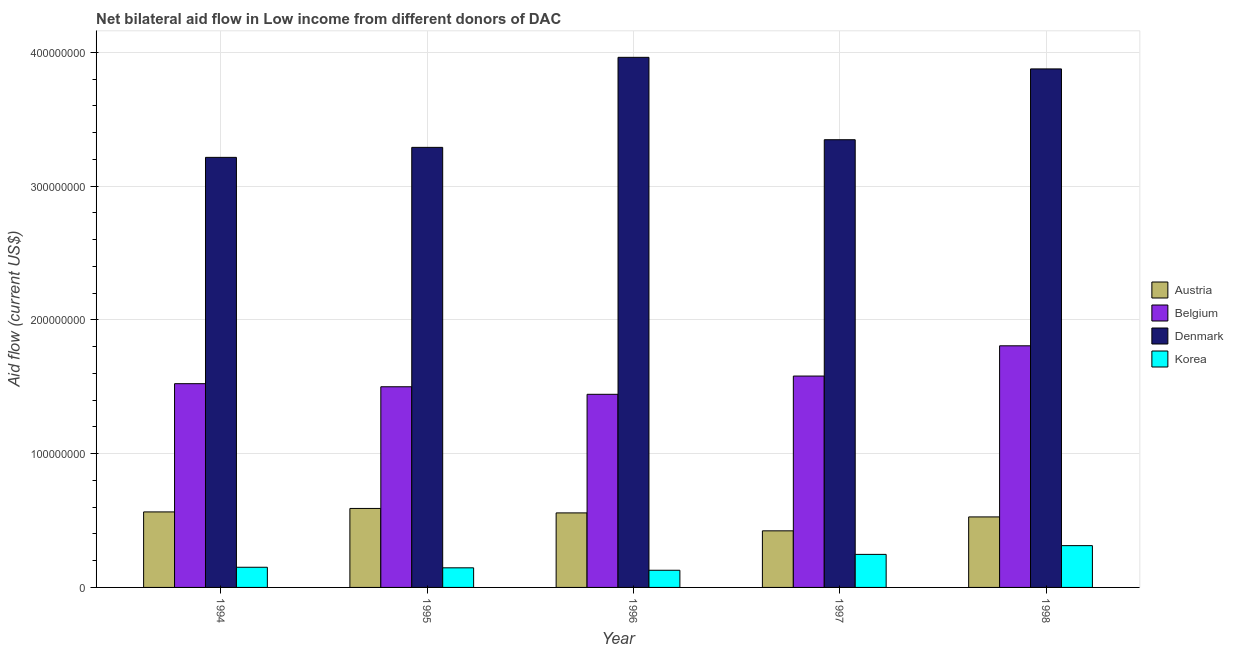Are the number of bars per tick equal to the number of legend labels?
Offer a terse response. Yes. Are the number of bars on each tick of the X-axis equal?
Give a very brief answer. Yes. How many bars are there on the 4th tick from the right?
Ensure brevity in your answer.  4. In how many cases, is the number of bars for a given year not equal to the number of legend labels?
Ensure brevity in your answer.  0. What is the amount of aid given by austria in 1997?
Provide a short and direct response. 4.23e+07. Across all years, what is the maximum amount of aid given by korea?
Keep it short and to the point. 3.12e+07. Across all years, what is the minimum amount of aid given by denmark?
Keep it short and to the point. 3.21e+08. What is the total amount of aid given by austria in the graph?
Offer a very short reply. 2.66e+08. What is the difference between the amount of aid given by denmark in 1994 and that in 1997?
Make the answer very short. -1.32e+07. What is the difference between the amount of aid given by austria in 1997 and the amount of aid given by korea in 1994?
Provide a short and direct response. -1.42e+07. What is the average amount of aid given by austria per year?
Your response must be concise. 5.32e+07. In how many years, is the amount of aid given by austria greater than 240000000 US$?
Ensure brevity in your answer.  0. What is the ratio of the amount of aid given by belgium in 1996 to that in 1997?
Give a very brief answer. 0.91. What is the difference between the highest and the second highest amount of aid given by denmark?
Keep it short and to the point. 8.66e+06. What is the difference between the highest and the lowest amount of aid given by korea?
Offer a very short reply. 1.84e+07. Is the sum of the amount of aid given by korea in 1997 and 1998 greater than the maximum amount of aid given by denmark across all years?
Ensure brevity in your answer.  Yes. Is it the case that in every year, the sum of the amount of aid given by korea and amount of aid given by denmark is greater than the sum of amount of aid given by austria and amount of aid given by belgium?
Offer a terse response. No. What does the 4th bar from the left in 1995 represents?
Your answer should be compact. Korea. Is it the case that in every year, the sum of the amount of aid given by austria and amount of aid given by belgium is greater than the amount of aid given by denmark?
Offer a terse response. No. Are the values on the major ticks of Y-axis written in scientific E-notation?
Your response must be concise. No. What is the title of the graph?
Offer a terse response. Net bilateral aid flow in Low income from different donors of DAC. What is the label or title of the X-axis?
Provide a short and direct response. Year. What is the Aid flow (current US$) in Austria in 1994?
Make the answer very short. 5.64e+07. What is the Aid flow (current US$) in Belgium in 1994?
Give a very brief answer. 1.52e+08. What is the Aid flow (current US$) in Denmark in 1994?
Provide a succinct answer. 3.21e+08. What is the Aid flow (current US$) in Korea in 1994?
Ensure brevity in your answer.  1.51e+07. What is the Aid flow (current US$) of Austria in 1995?
Your response must be concise. 5.90e+07. What is the Aid flow (current US$) of Belgium in 1995?
Your response must be concise. 1.50e+08. What is the Aid flow (current US$) of Denmark in 1995?
Your answer should be very brief. 3.29e+08. What is the Aid flow (current US$) of Korea in 1995?
Provide a succinct answer. 1.47e+07. What is the Aid flow (current US$) in Austria in 1996?
Provide a short and direct response. 5.57e+07. What is the Aid flow (current US$) in Belgium in 1996?
Provide a succinct answer. 1.44e+08. What is the Aid flow (current US$) in Denmark in 1996?
Your response must be concise. 3.96e+08. What is the Aid flow (current US$) of Korea in 1996?
Provide a short and direct response. 1.28e+07. What is the Aid flow (current US$) in Austria in 1997?
Offer a terse response. 4.23e+07. What is the Aid flow (current US$) in Belgium in 1997?
Offer a terse response. 1.58e+08. What is the Aid flow (current US$) in Denmark in 1997?
Offer a terse response. 3.35e+08. What is the Aid flow (current US$) of Korea in 1997?
Make the answer very short. 2.47e+07. What is the Aid flow (current US$) in Austria in 1998?
Your answer should be very brief. 5.27e+07. What is the Aid flow (current US$) in Belgium in 1998?
Your answer should be very brief. 1.81e+08. What is the Aid flow (current US$) in Denmark in 1998?
Your answer should be very brief. 3.88e+08. What is the Aid flow (current US$) in Korea in 1998?
Provide a short and direct response. 3.12e+07. Across all years, what is the maximum Aid flow (current US$) in Austria?
Your answer should be compact. 5.90e+07. Across all years, what is the maximum Aid flow (current US$) in Belgium?
Offer a terse response. 1.81e+08. Across all years, what is the maximum Aid flow (current US$) of Denmark?
Provide a short and direct response. 3.96e+08. Across all years, what is the maximum Aid flow (current US$) of Korea?
Your answer should be compact. 3.12e+07. Across all years, what is the minimum Aid flow (current US$) of Austria?
Give a very brief answer. 4.23e+07. Across all years, what is the minimum Aid flow (current US$) of Belgium?
Offer a very short reply. 1.44e+08. Across all years, what is the minimum Aid flow (current US$) of Denmark?
Your response must be concise. 3.21e+08. Across all years, what is the minimum Aid flow (current US$) in Korea?
Provide a short and direct response. 1.28e+07. What is the total Aid flow (current US$) in Austria in the graph?
Ensure brevity in your answer.  2.66e+08. What is the total Aid flow (current US$) of Belgium in the graph?
Give a very brief answer. 7.85e+08. What is the total Aid flow (current US$) in Denmark in the graph?
Your answer should be very brief. 1.77e+09. What is the total Aid flow (current US$) in Korea in the graph?
Provide a succinct answer. 9.85e+07. What is the difference between the Aid flow (current US$) in Austria in 1994 and that in 1995?
Your answer should be very brief. -2.59e+06. What is the difference between the Aid flow (current US$) in Belgium in 1994 and that in 1995?
Ensure brevity in your answer.  2.29e+06. What is the difference between the Aid flow (current US$) of Denmark in 1994 and that in 1995?
Make the answer very short. -7.47e+06. What is the difference between the Aid flow (current US$) in Korea in 1994 and that in 1995?
Your answer should be very brief. 4.20e+05. What is the difference between the Aid flow (current US$) of Austria in 1994 and that in 1996?
Your response must be concise. 7.40e+05. What is the difference between the Aid flow (current US$) of Belgium in 1994 and that in 1996?
Keep it short and to the point. 7.94e+06. What is the difference between the Aid flow (current US$) in Denmark in 1994 and that in 1996?
Your answer should be compact. -7.48e+07. What is the difference between the Aid flow (current US$) in Korea in 1994 and that in 1996?
Keep it short and to the point. 2.25e+06. What is the difference between the Aid flow (current US$) in Austria in 1994 and that in 1997?
Give a very brief answer. 1.42e+07. What is the difference between the Aid flow (current US$) of Belgium in 1994 and that in 1997?
Ensure brevity in your answer.  -5.70e+06. What is the difference between the Aid flow (current US$) in Denmark in 1994 and that in 1997?
Ensure brevity in your answer.  -1.32e+07. What is the difference between the Aid flow (current US$) in Korea in 1994 and that in 1997?
Offer a very short reply. -9.62e+06. What is the difference between the Aid flow (current US$) of Austria in 1994 and that in 1998?
Ensure brevity in your answer.  3.74e+06. What is the difference between the Aid flow (current US$) of Belgium in 1994 and that in 1998?
Offer a terse response. -2.83e+07. What is the difference between the Aid flow (current US$) of Denmark in 1994 and that in 1998?
Give a very brief answer. -6.61e+07. What is the difference between the Aid flow (current US$) in Korea in 1994 and that in 1998?
Your answer should be compact. -1.62e+07. What is the difference between the Aid flow (current US$) of Austria in 1995 and that in 1996?
Your answer should be very brief. 3.33e+06. What is the difference between the Aid flow (current US$) of Belgium in 1995 and that in 1996?
Give a very brief answer. 5.65e+06. What is the difference between the Aid flow (current US$) in Denmark in 1995 and that in 1996?
Offer a terse response. -6.73e+07. What is the difference between the Aid flow (current US$) in Korea in 1995 and that in 1996?
Make the answer very short. 1.83e+06. What is the difference between the Aid flow (current US$) of Austria in 1995 and that in 1997?
Keep it short and to the point. 1.67e+07. What is the difference between the Aid flow (current US$) in Belgium in 1995 and that in 1997?
Provide a succinct answer. -7.99e+06. What is the difference between the Aid flow (current US$) in Denmark in 1995 and that in 1997?
Provide a short and direct response. -5.72e+06. What is the difference between the Aid flow (current US$) of Korea in 1995 and that in 1997?
Offer a terse response. -1.00e+07. What is the difference between the Aid flow (current US$) in Austria in 1995 and that in 1998?
Give a very brief answer. 6.33e+06. What is the difference between the Aid flow (current US$) in Belgium in 1995 and that in 1998?
Make the answer very short. -3.06e+07. What is the difference between the Aid flow (current US$) of Denmark in 1995 and that in 1998?
Your answer should be very brief. -5.86e+07. What is the difference between the Aid flow (current US$) in Korea in 1995 and that in 1998?
Offer a terse response. -1.66e+07. What is the difference between the Aid flow (current US$) in Austria in 1996 and that in 1997?
Give a very brief answer. 1.34e+07. What is the difference between the Aid flow (current US$) in Belgium in 1996 and that in 1997?
Offer a terse response. -1.36e+07. What is the difference between the Aid flow (current US$) of Denmark in 1996 and that in 1997?
Your answer should be compact. 6.16e+07. What is the difference between the Aid flow (current US$) of Korea in 1996 and that in 1997?
Your response must be concise. -1.19e+07. What is the difference between the Aid flow (current US$) of Austria in 1996 and that in 1998?
Your answer should be compact. 3.00e+06. What is the difference between the Aid flow (current US$) in Belgium in 1996 and that in 1998?
Offer a very short reply. -3.63e+07. What is the difference between the Aid flow (current US$) in Denmark in 1996 and that in 1998?
Give a very brief answer. 8.66e+06. What is the difference between the Aid flow (current US$) in Korea in 1996 and that in 1998?
Provide a succinct answer. -1.84e+07. What is the difference between the Aid flow (current US$) of Austria in 1997 and that in 1998?
Your answer should be compact. -1.04e+07. What is the difference between the Aid flow (current US$) of Belgium in 1997 and that in 1998?
Your answer should be compact. -2.26e+07. What is the difference between the Aid flow (current US$) in Denmark in 1997 and that in 1998?
Provide a short and direct response. -5.29e+07. What is the difference between the Aid flow (current US$) of Korea in 1997 and that in 1998?
Make the answer very short. -6.54e+06. What is the difference between the Aid flow (current US$) of Austria in 1994 and the Aid flow (current US$) of Belgium in 1995?
Your answer should be compact. -9.36e+07. What is the difference between the Aid flow (current US$) of Austria in 1994 and the Aid flow (current US$) of Denmark in 1995?
Make the answer very short. -2.72e+08. What is the difference between the Aid flow (current US$) of Austria in 1994 and the Aid flow (current US$) of Korea in 1995?
Keep it short and to the point. 4.18e+07. What is the difference between the Aid flow (current US$) in Belgium in 1994 and the Aid flow (current US$) in Denmark in 1995?
Provide a short and direct response. -1.77e+08. What is the difference between the Aid flow (current US$) in Belgium in 1994 and the Aid flow (current US$) in Korea in 1995?
Your answer should be compact. 1.38e+08. What is the difference between the Aid flow (current US$) in Denmark in 1994 and the Aid flow (current US$) in Korea in 1995?
Your answer should be very brief. 3.07e+08. What is the difference between the Aid flow (current US$) of Austria in 1994 and the Aid flow (current US$) of Belgium in 1996?
Provide a succinct answer. -8.79e+07. What is the difference between the Aid flow (current US$) in Austria in 1994 and the Aid flow (current US$) in Denmark in 1996?
Provide a short and direct response. -3.40e+08. What is the difference between the Aid flow (current US$) in Austria in 1994 and the Aid flow (current US$) in Korea in 1996?
Offer a very short reply. 4.36e+07. What is the difference between the Aid flow (current US$) of Belgium in 1994 and the Aid flow (current US$) of Denmark in 1996?
Make the answer very short. -2.44e+08. What is the difference between the Aid flow (current US$) of Belgium in 1994 and the Aid flow (current US$) of Korea in 1996?
Ensure brevity in your answer.  1.39e+08. What is the difference between the Aid flow (current US$) of Denmark in 1994 and the Aid flow (current US$) of Korea in 1996?
Your answer should be compact. 3.09e+08. What is the difference between the Aid flow (current US$) in Austria in 1994 and the Aid flow (current US$) in Belgium in 1997?
Ensure brevity in your answer.  -1.02e+08. What is the difference between the Aid flow (current US$) in Austria in 1994 and the Aid flow (current US$) in Denmark in 1997?
Your response must be concise. -2.78e+08. What is the difference between the Aid flow (current US$) of Austria in 1994 and the Aid flow (current US$) of Korea in 1997?
Offer a very short reply. 3.18e+07. What is the difference between the Aid flow (current US$) in Belgium in 1994 and the Aid flow (current US$) in Denmark in 1997?
Provide a succinct answer. -1.82e+08. What is the difference between the Aid flow (current US$) of Belgium in 1994 and the Aid flow (current US$) of Korea in 1997?
Your answer should be very brief. 1.28e+08. What is the difference between the Aid flow (current US$) in Denmark in 1994 and the Aid flow (current US$) in Korea in 1997?
Keep it short and to the point. 2.97e+08. What is the difference between the Aid flow (current US$) in Austria in 1994 and the Aid flow (current US$) in Belgium in 1998?
Offer a very short reply. -1.24e+08. What is the difference between the Aid flow (current US$) in Austria in 1994 and the Aid flow (current US$) in Denmark in 1998?
Ensure brevity in your answer.  -3.31e+08. What is the difference between the Aid flow (current US$) of Austria in 1994 and the Aid flow (current US$) of Korea in 1998?
Your answer should be very brief. 2.52e+07. What is the difference between the Aid flow (current US$) of Belgium in 1994 and the Aid flow (current US$) of Denmark in 1998?
Offer a terse response. -2.35e+08. What is the difference between the Aid flow (current US$) of Belgium in 1994 and the Aid flow (current US$) of Korea in 1998?
Offer a terse response. 1.21e+08. What is the difference between the Aid flow (current US$) of Denmark in 1994 and the Aid flow (current US$) of Korea in 1998?
Offer a very short reply. 2.90e+08. What is the difference between the Aid flow (current US$) of Austria in 1995 and the Aid flow (current US$) of Belgium in 1996?
Your answer should be compact. -8.53e+07. What is the difference between the Aid flow (current US$) of Austria in 1995 and the Aid flow (current US$) of Denmark in 1996?
Your response must be concise. -3.37e+08. What is the difference between the Aid flow (current US$) of Austria in 1995 and the Aid flow (current US$) of Korea in 1996?
Give a very brief answer. 4.62e+07. What is the difference between the Aid flow (current US$) of Belgium in 1995 and the Aid flow (current US$) of Denmark in 1996?
Your answer should be compact. -2.46e+08. What is the difference between the Aid flow (current US$) in Belgium in 1995 and the Aid flow (current US$) in Korea in 1996?
Your answer should be very brief. 1.37e+08. What is the difference between the Aid flow (current US$) in Denmark in 1995 and the Aid flow (current US$) in Korea in 1996?
Your response must be concise. 3.16e+08. What is the difference between the Aid flow (current US$) in Austria in 1995 and the Aid flow (current US$) in Belgium in 1997?
Give a very brief answer. -9.90e+07. What is the difference between the Aid flow (current US$) of Austria in 1995 and the Aid flow (current US$) of Denmark in 1997?
Your response must be concise. -2.76e+08. What is the difference between the Aid flow (current US$) of Austria in 1995 and the Aid flow (current US$) of Korea in 1997?
Provide a short and direct response. 3.43e+07. What is the difference between the Aid flow (current US$) in Belgium in 1995 and the Aid flow (current US$) in Denmark in 1997?
Make the answer very short. -1.85e+08. What is the difference between the Aid flow (current US$) of Belgium in 1995 and the Aid flow (current US$) of Korea in 1997?
Provide a succinct answer. 1.25e+08. What is the difference between the Aid flow (current US$) of Denmark in 1995 and the Aid flow (current US$) of Korea in 1997?
Your answer should be very brief. 3.04e+08. What is the difference between the Aid flow (current US$) in Austria in 1995 and the Aid flow (current US$) in Belgium in 1998?
Your answer should be very brief. -1.22e+08. What is the difference between the Aid flow (current US$) of Austria in 1995 and the Aid flow (current US$) of Denmark in 1998?
Provide a succinct answer. -3.29e+08. What is the difference between the Aid flow (current US$) in Austria in 1995 and the Aid flow (current US$) in Korea in 1998?
Offer a very short reply. 2.78e+07. What is the difference between the Aid flow (current US$) of Belgium in 1995 and the Aid flow (current US$) of Denmark in 1998?
Give a very brief answer. -2.38e+08. What is the difference between the Aid flow (current US$) of Belgium in 1995 and the Aid flow (current US$) of Korea in 1998?
Offer a terse response. 1.19e+08. What is the difference between the Aid flow (current US$) in Denmark in 1995 and the Aid flow (current US$) in Korea in 1998?
Give a very brief answer. 2.98e+08. What is the difference between the Aid flow (current US$) in Austria in 1996 and the Aid flow (current US$) in Belgium in 1997?
Keep it short and to the point. -1.02e+08. What is the difference between the Aid flow (current US$) in Austria in 1996 and the Aid flow (current US$) in Denmark in 1997?
Make the answer very short. -2.79e+08. What is the difference between the Aid flow (current US$) in Austria in 1996 and the Aid flow (current US$) in Korea in 1997?
Give a very brief answer. 3.10e+07. What is the difference between the Aid flow (current US$) of Belgium in 1996 and the Aid flow (current US$) of Denmark in 1997?
Your answer should be very brief. -1.90e+08. What is the difference between the Aid flow (current US$) of Belgium in 1996 and the Aid flow (current US$) of Korea in 1997?
Offer a terse response. 1.20e+08. What is the difference between the Aid flow (current US$) in Denmark in 1996 and the Aid flow (current US$) in Korea in 1997?
Offer a very short reply. 3.72e+08. What is the difference between the Aid flow (current US$) of Austria in 1996 and the Aid flow (current US$) of Belgium in 1998?
Your answer should be very brief. -1.25e+08. What is the difference between the Aid flow (current US$) in Austria in 1996 and the Aid flow (current US$) in Denmark in 1998?
Ensure brevity in your answer.  -3.32e+08. What is the difference between the Aid flow (current US$) of Austria in 1996 and the Aid flow (current US$) of Korea in 1998?
Ensure brevity in your answer.  2.45e+07. What is the difference between the Aid flow (current US$) in Belgium in 1996 and the Aid flow (current US$) in Denmark in 1998?
Your answer should be very brief. -2.43e+08. What is the difference between the Aid flow (current US$) in Belgium in 1996 and the Aid flow (current US$) in Korea in 1998?
Your answer should be very brief. 1.13e+08. What is the difference between the Aid flow (current US$) of Denmark in 1996 and the Aid flow (current US$) of Korea in 1998?
Your response must be concise. 3.65e+08. What is the difference between the Aid flow (current US$) of Austria in 1997 and the Aid flow (current US$) of Belgium in 1998?
Offer a very short reply. -1.38e+08. What is the difference between the Aid flow (current US$) of Austria in 1997 and the Aid flow (current US$) of Denmark in 1998?
Your response must be concise. -3.45e+08. What is the difference between the Aid flow (current US$) in Austria in 1997 and the Aid flow (current US$) in Korea in 1998?
Your answer should be very brief. 1.11e+07. What is the difference between the Aid flow (current US$) of Belgium in 1997 and the Aid flow (current US$) of Denmark in 1998?
Your answer should be very brief. -2.30e+08. What is the difference between the Aid flow (current US$) of Belgium in 1997 and the Aid flow (current US$) of Korea in 1998?
Offer a very short reply. 1.27e+08. What is the difference between the Aid flow (current US$) in Denmark in 1997 and the Aid flow (current US$) in Korea in 1998?
Ensure brevity in your answer.  3.03e+08. What is the average Aid flow (current US$) in Austria per year?
Give a very brief answer. 5.32e+07. What is the average Aid flow (current US$) of Belgium per year?
Offer a very short reply. 1.57e+08. What is the average Aid flow (current US$) of Denmark per year?
Offer a terse response. 3.54e+08. What is the average Aid flow (current US$) of Korea per year?
Offer a very short reply. 1.97e+07. In the year 1994, what is the difference between the Aid flow (current US$) of Austria and Aid flow (current US$) of Belgium?
Offer a terse response. -9.58e+07. In the year 1994, what is the difference between the Aid flow (current US$) in Austria and Aid flow (current US$) in Denmark?
Keep it short and to the point. -2.65e+08. In the year 1994, what is the difference between the Aid flow (current US$) of Austria and Aid flow (current US$) of Korea?
Ensure brevity in your answer.  4.14e+07. In the year 1994, what is the difference between the Aid flow (current US$) in Belgium and Aid flow (current US$) in Denmark?
Make the answer very short. -1.69e+08. In the year 1994, what is the difference between the Aid flow (current US$) in Belgium and Aid flow (current US$) in Korea?
Keep it short and to the point. 1.37e+08. In the year 1994, what is the difference between the Aid flow (current US$) of Denmark and Aid flow (current US$) of Korea?
Offer a terse response. 3.06e+08. In the year 1995, what is the difference between the Aid flow (current US$) in Austria and Aid flow (current US$) in Belgium?
Your answer should be compact. -9.10e+07. In the year 1995, what is the difference between the Aid flow (current US$) of Austria and Aid flow (current US$) of Denmark?
Provide a succinct answer. -2.70e+08. In the year 1995, what is the difference between the Aid flow (current US$) of Austria and Aid flow (current US$) of Korea?
Offer a very short reply. 4.44e+07. In the year 1995, what is the difference between the Aid flow (current US$) in Belgium and Aid flow (current US$) in Denmark?
Your answer should be compact. -1.79e+08. In the year 1995, what is the difference between the Aid flow (current US$) in Belgium and Aid flow (current US$) in Korea?
Your answer should be compact. 1.35e+08. In the year 1995, what is the difference between the Aid flow (current US$) in Denmark and Aid flow (current US$) in Korea?
Make the answer very short. 3.14e+08. In the year 1996, what is the difference between the Aid flow (current US$) in Austria and Aid flow (current US$) in Belgium?
Give a very brief answer. -8.86e+07. In the year 1996, what is the difference between the Aid flow (current US$) in Austria and Aid flow (current US$) in Denmark?
Provide a succinct answer. -3.41e+08. In the year 1996, what is the difference between the Aid flow (current US$) of Austria and Aid flow (current US$) of Korea?
Provide a succinct answer. 4.29e+07. In the year 1996, what is the difference between the Aid flow (current US$) of Belgium and Aid flow (current US$) of Denmark?
Keep it short and to the point. -2.52e+08. In the year 1996, what is the difference between the Aid flow (current US$) of Belgium and Aid flow (current US$) of Korea?
Provide a succinct answer. 1.32e+08. In the year 1996, what is the difference between the Aid flow (current US$) in Denmark and Aid flow (current US$) in Korea?
Keep it short and to the point. 3.83e+08. In the year 1997, what is the difference between the Aid flow (current US$) in Austria and Aid flow (current US$) in Belgium?
Your answer should be very brief. -1.16e+08. In the year 1997, what is the difference between the Aid flow (current US$) of Austria and Aid flow (current US$) of Denmark?
Your answer should be very brief. -2.92e+08. In the year 1997, what is the difference between the Aid flow (current US$) in Austria and Aid flow (current US$) in Korea?
Make the answer very short. 1.76e+07. In the year 1997, what is the difference between the Aid flow (current US$) in Belgium and Aid flow (current US$) in Denmark?
Offer a very short reply. -1.77e+08. In the year 1997, what is the difference between the Aid flow (current US$) of Belgium and Aid flow (current US$) of Korea?
Offer a very short reply. 1.33e+08. In the year 1997, what is the difference between the Aid flow (current US$) of Denmark and Aid flow (current US$) of Korea?
Offer a terse response. 3.10e+08. In the year 1998, what is the difference between the Aid flow (current US$) of Austria and Aid flow (current US$) of Belgium?
Your answer should be compact. -1.28e+08. In the year 1998, what is the difference between the Aid flow (current US$) of Austria and Aid flow (current US$) of Denmark?
Offer a very short reply. -3.35e+08. In the year 1998, what is the difference between the Aid flow (current US$) of Austria and Aid flow (current US$) of Korea?
Offer a terse response. 2.15e+07. In the year 1998, what is the difference between the Aid flow (current US$) in Belgium and Aid flow (current US$) in Denmark?
Keep it short and to the point. -2.07e+08. In the year 1998, what is the difference between the Aid flow (current US$) in Belgium and Aid flow (current US$) in Korea?
Offer a terse response. 1.49e+08. In the year 1998, what is the difference between the Aid flow (current US$) of Denmark and Aid flow (current US$) of Korea?
Your answer should be compact. 3.56e+08. What is the ratio of the Aid flow (current US$) in Austria in 1994 to that in 1995?
Make the answer very short. 0.96. What is the ratio of the Aid flow (current US$) in Belgium in 1994 to that in 1995?
Give a very brief answer. 1.02. What is the ratio of the Aid flow (current US$) in Denmark in 1994 to that in 1995?
Your response must be concise. 0.98. What is the ratio of the Aid flow (current US$) of Korea in 1994 to that in 1995?
Offer a very short reply. 1.03. What is the ratio of the Aid flow (current US$) in Austria in 1994 to that in 1996?
Your answer should be very brief. 1.01. What is the ratio of the Aid flow (current US$) in Belgium in 1994 to that in 1996?
Provide a short and direct response. 1.05. What is the ratio of the Aid flow (current US$) in Denmark in 1994 to that in 1996?
Offer a terse response. 0.81. What is the ratio of the Aid flow (current US$) in Korea in 1994 to that in 1996?
Keep it short and to the point. 1.18. What is the ratio of the Aid flow (current US$) of Austria in 1994 to that in 1997?
Provide a succinct answer. 1.33. What is the ratio of the Aid flow (current US$) in Belgium in 1994 to that in 1997?
Offer a terse response. 0.96. What is the ratio of the Aid flow (current US$) in Denmark in 1994 to that in 1997?
Give a very brief answer. 0.96. What is the ratio of the Aid flow (current US$) in Korea in 1994 to that in 1997?
Give a very brief answer. 0.61. What is the ratio of the Aid flow (current US$) in Austria in 1994 to that in 1998?
Provide a short and direct response. 1.07. What is the ratio of the Aid flow (current US$) in Belgium in 1994 to that in 1998?
Give a very brief answer. 0.84. What is the ratio of the Aid flow (current US$) in Denmark in 1994 to that in 1998?
Offer a terse response. 0.83. What is the ratio of the Aid flow (current US$) in Korea in 1994 to that in 1998?
Make the answer very short. 0.48. What is the ratio of the Aid flow (current US$) of Austria in 1995 to that in 1996?
Keep it short and to the point. 1.06. What is the ratio of the Aid flow (current US$) of Belgium in 1995 to that in 1996?
Give a very brief answer. 1.04. What is the ratio of the Aid flow (current US$) of Denmark in 1995 to that in 1996?
Keep it short and to the point. 0.83. What is the ratio of the Aid flow (current US$) of Korea in 1995 to that in 1996?
Keep it short and to the point. 1.14. What is the ratio of the Aid flow (current US$) in Austria in 1995 to that in 1997?
Your answer should be compact. 1.4. What is the ratio of the Aid flow (current US$) in Belgium in 1995 to that in 1997?
Your response must be concise. 0.95. What is the ratio of the Aid flow (current US$) in Denmark in 1995 to that in 1997?
Provide a short and direct response. 0.98. What is the ratio of the Aid flow (current US$) in Korea in 1995 to that in 1997?
Ensure brevity in your answer.  0.59. What is the ratio of the Aid flow (current US$) in Austria in 1995 to that in 1998?
Provide a succinct answer. 1.12. What is the ratio of the Aid flow (current US$) of Belgium in 1995 to that in 1998?
Give a very brief answer. 0.83. What is the ratio of the Aid flow (current US$) of Denmark in 1995 to that in 1998?
Offer a very short reply. 0.85. What is the ratio of the Aid flow (current US$) in Korea in 1995 to that in 1998?
Your answer should be very brief. 0.47. What is the ratio of the Aid flow (current US$) in Austria in 1996 to that in 1997?
Keep it short and to the point. 1.32. What is the ratio of the Aid flow (current US$) of Belgium in 1996 to that in 1997?
Ensure brevity in your answer.  0.91. What is the ratio of the Aid flow (current US$) in Denmark in 1996 to that in 1997?
Provide a succinct answer. 1.18. What is the ratio of the Aid flow (current US$) in Korea in 1996 to that in 1997?
Your answer should be compact. 0.52. What is the ratio of the Aid flow (current US$) in Austria in 1996 to that in 1998?
Offer a terse response. 1.06. What is the ratio of the Aid flow (current US$) of Belgium in 1996 to that in 1998?
Provide a succinct answer. 0.8. What is the ratio of the Aid flow (current US$) of Denmark in 1996 to that in 1998?
Give a very brief answer. 1.02. What is the ratio of the Aid flow (current US$) in Korea in 1996 to that in 1998?
Ensure brevity in your answer.  0.41. What is the ratio of the Aid flow (current US$) of Austria in 1997 to that in 1998?
Your answer should be compact. 0.8. What is the ratio of the Aid flow (current US$) in Belgium in 1997 to that in 1998?
Your answer should be compact. 0.87. What is the ratio of the Aid flow (current US$) in Denmark in 1997 to that in 1998?
Offer a terse response. 0.86. What is the ratio of the Aid flow (current US$) of Korea in 1997 to that in 1998?
Provide a short and direct response. 0.79. What is the difference between the highest and the second highest Aid flow (current US$) in Austria?
Provide a short and direct response. 2.59e+06. What is the difference between the highest and the second highest Aid flow (current US$) of Belgium?
Provide a succinct answer. 2.26e+07. What is the difference between the highest and the second highest Aid flow (current US$) of Denmark?
Provide a succinct answer. 8.66e+06. What is the difference between the highest and the second highest Aid flow (current US$) in Korea?
Make the answer very short. 6.54e+06. What is the difference between the highest and the lowest Aid flow (current US$) in Austria?
Provide a succinct answer. 1.67e+07. What is the difference between the highest and the lowest Aid flow (current US$) in Belgium?
Ensure brevity in your answer.  3.63e+07. What is the difference between the highest and the lowest Aid flow (current US$) in Denmark?
Keep it short and to the point. 7.48e+07. What is the difference between the highest and the lowest Aid flow (current US$) of Korea?
Ensure brevity in your answer.  1.84e+07. 